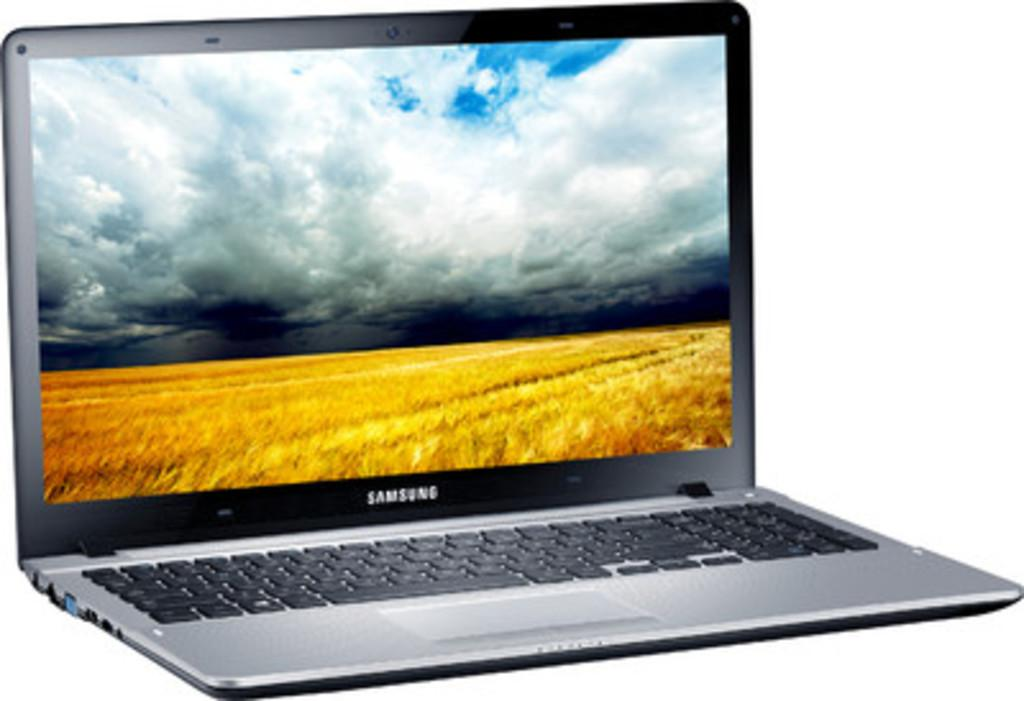Provide a one-sentence caption for the provided image. a sansung flat screen laptop with an open field on the screen saver. 